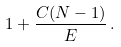Convert formula to latex. <formula><loc_0><loc_0><loc_500><loc_500>1 + \frac { C ( N - 1 ) } { E } \, .</formula> 